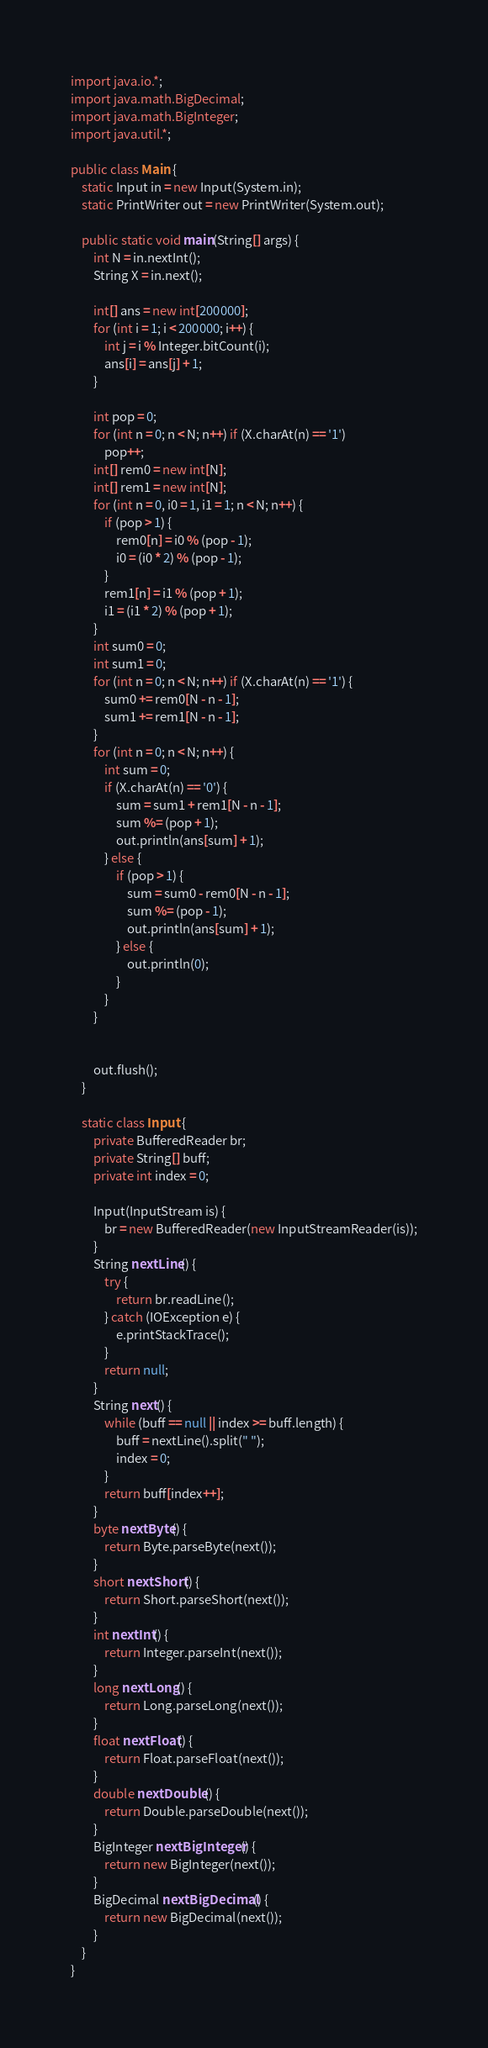<code> <loc_0><loc_0><loc_500><loc_500><_Java_>import java.io.*;
import java.math.BigDecimal;
import java.math.BigInteger;
import java.util.*;

public class Main {
    static Input in = new Input(System.in);
    static PrintWriter out = new PrintWriter(System.out);

    public static void main(String[] args) {
        int N = in.nextInt();
        String X = in.next();

        int[] ans = new int[200000];
        for (int i = 1; i < 200000; i++) {
            int j = i % Integer.bitCount(i);
            ans[i] = ans[j] + 1;
        }

        int pop = 0;
        for (int n = 0; n < N; n++) if (X.charAt(n) == '1')
            pop++;
        int[] rem0 = new int[N];
        int[] rem1 = new int[N];
        for (int n = 0, i0 = 1, i1 = 1; n < N; n++) {
            if (pop > 1) {
                rem0[n] = i0 % (pop - 1);
                i0 = (i0 * 2) % (pop - 1);
            }
            rem1[n] = i1 % (pop + 1);
            i1 = (i1 * 2) % (pop + 1);
        }
        int sum0 = 0;
        int sum1 = 0;
        for (int n = 0; n < N; n++) if (X.charAt(n) == '1') {
            sum0 += rem0[N - n - 1];
            sum1 += rem1[N - n - 1];
        }
        for (int n = 0; n < N; n++) {
            int sum = 0;
            if (X.charAt(n) == '0') {
                sum = sum1 + rem1[N - n - 1];
                sum %= (pop + 1);
                out.println(ans[sum] + 1);
            } else {
                if (pop > 1) {
                    sum = sum0 - rem0[N - n - 1];
                    sum %= (pop - 1);
                    out.println(ans[sum] + 1);
                } else {
                    out.println(0);
                }
            }
        }


        out.flush();
    }

    static class Input {
        private BufferedReader br;
        private String[] buff;
        private int index = 0;

        Input(InputStream is) {
            br = new BufferedReader(new InputStreamReader(is));
        }
        String nextLine() {
            try {
                return br.readLine();
            } catch (IOException e) {
                e.printStackTrace();
            }
            return null;
        }
        String next() {
            while (buff == null || index >= buff.length) {
                buff = nextLine().split(" ");
                index = 0;
            }
            return buff[index++];
        }
        byte nextByte() {
            return Byte.parseByte(next());
        }
        short nextShort() {
            return Short.parseShort(next());
        }
        int nextInt() {
            return Integer.parseInt(next());
        }
        long nextLong() {
            return Long.parseLong(next());
        }
        float nextFloat() {
            return Float.parseFloat(next());
        }
        double nextDouble() {
            return Double.parseDouble(next());
        }
        BigInteger nextBigInteger() {
            return new BigInteger(next());
        }
        BigDecimal nextBigDecimal() {
            return new BigDecimal(next());
        }
    }
}

</code> 